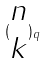<formula> <loc_0><loc_0><loc_500><loc_500>( \begin{matrix} n \\ k \end{matrix} ) _ { q }</formula> 